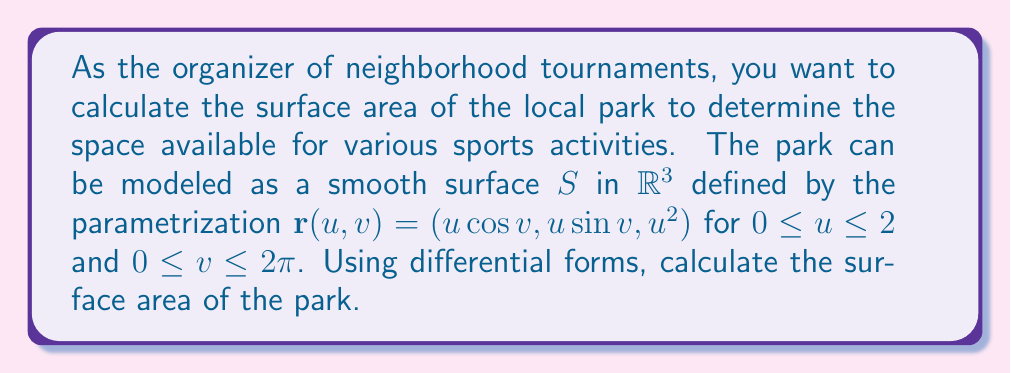Can you answer this question? To calculate the surface area using differential forms, we'll follow these steps:

1) First, we need to find the tangent vectors $\mathbf{r}_u$ and $\mathbf{r}_v$:

   $\mathbf{r}_u = (\cos v, \sin v, 2u)$
   $\mathbf{r}_v = (-u\sin v, u\cos v, 0)$

2) The surface area element is given by the magnitude of the cross product of these vectors:

   $dS = |\mathbf{r}_u \times \mathbf{r}_v| \, du \, dv$

3) Calculate the cross product:

   $\mathbf{r}_u \times \mathbf{r}_v = (u\cos v, u\sin v, -u) \cdot (2u)$
                                    $= (2u^2\cos v, 2u^2\sin v, -2u^2)$

4) Calculate the magnitude:

   $|\mathbf{r}_u \times \mathbf{r}_v| = \sqrt{(2u^2\cos v)^2 + (2u^2\sin v)^2 + (-2u^2)^2}$
                                       $= \sqrt{4u^4\cos^2 v + 4u^4\sin^2 v + 4u^4}$
                                       $= \sqrt{4u^4(\cos^2 v + \sin^2 v + 1)}$
                                       $= \sqrt{4u^4 \cdot 2}$
                                       $= 2u^2\sqrt{2}$

5) Therefore, the surface area element in differential form is:

   $dS = 2u^2\sqrt{2} \, du \, dv$

6) To find the total surface area, we integrate this over the given domain:

   $A = \int_0^{2\pi} \int_0^2 2u^2\sqrt{2} \, du \, dv$

7) Evaluate the integral:

   $A = 2\sqrt{2} \int_0^{2\pi} \left[ \frac{2u^3}{3} \right]_0^2 \, dv$
      $= 2\sqrt{2} \int_0^{2\pi} \frac{16}{3} \, dv$
      $= 2\sqrt{2} \cdot \frac{16}{3} \cdot 2\pi$
      $= \frac{64\pi\sqrt{2}}{3}$

Thus, the surface area of the park is $\frac{64\pi\sqrt{2}}{3}$ square units.
Answer: $\frac{64\pi\sqrt{2}}{3}$ square units 